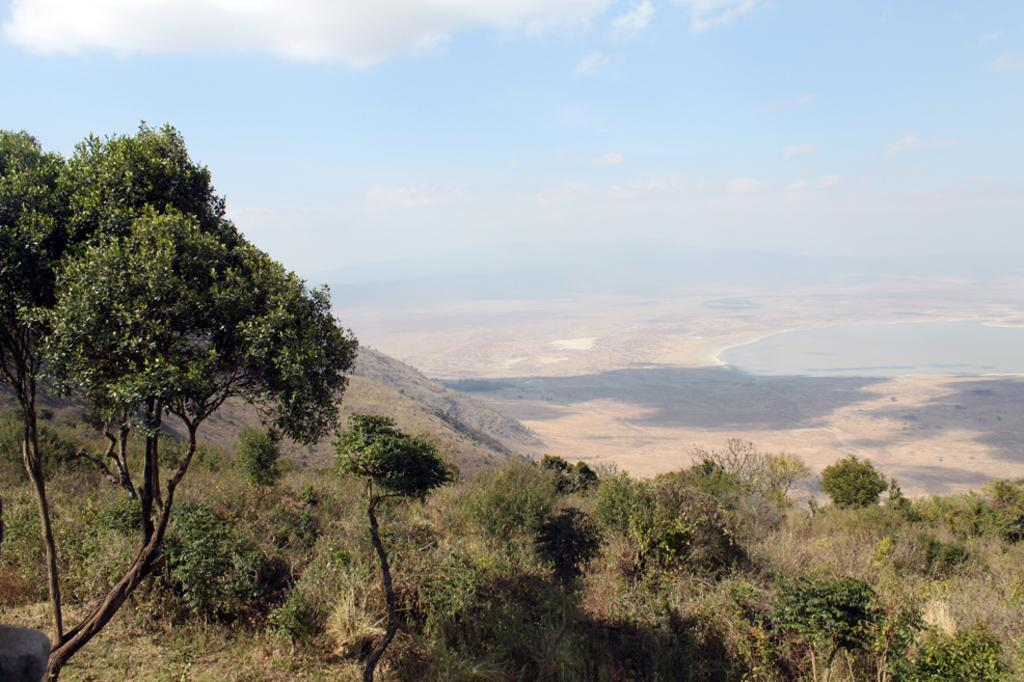What types of vegetation can be seen in the foreground of the image? There are trees and plants in the foreground of the image. What can be seen in the background of the image? The sky is visible in the image. What is the condition of the sky in the image? There are clouds in the sky. What type of knee can be seen in the image? There is no knee present in the image. Are there any berries visible in the image? There is no mention of berries in the provided facts, so it cannot be determined if they are present in the image. 